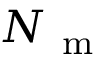<formula> <loc_0><loc_0><loc_500><loc_500>N _ { m }</formula> 